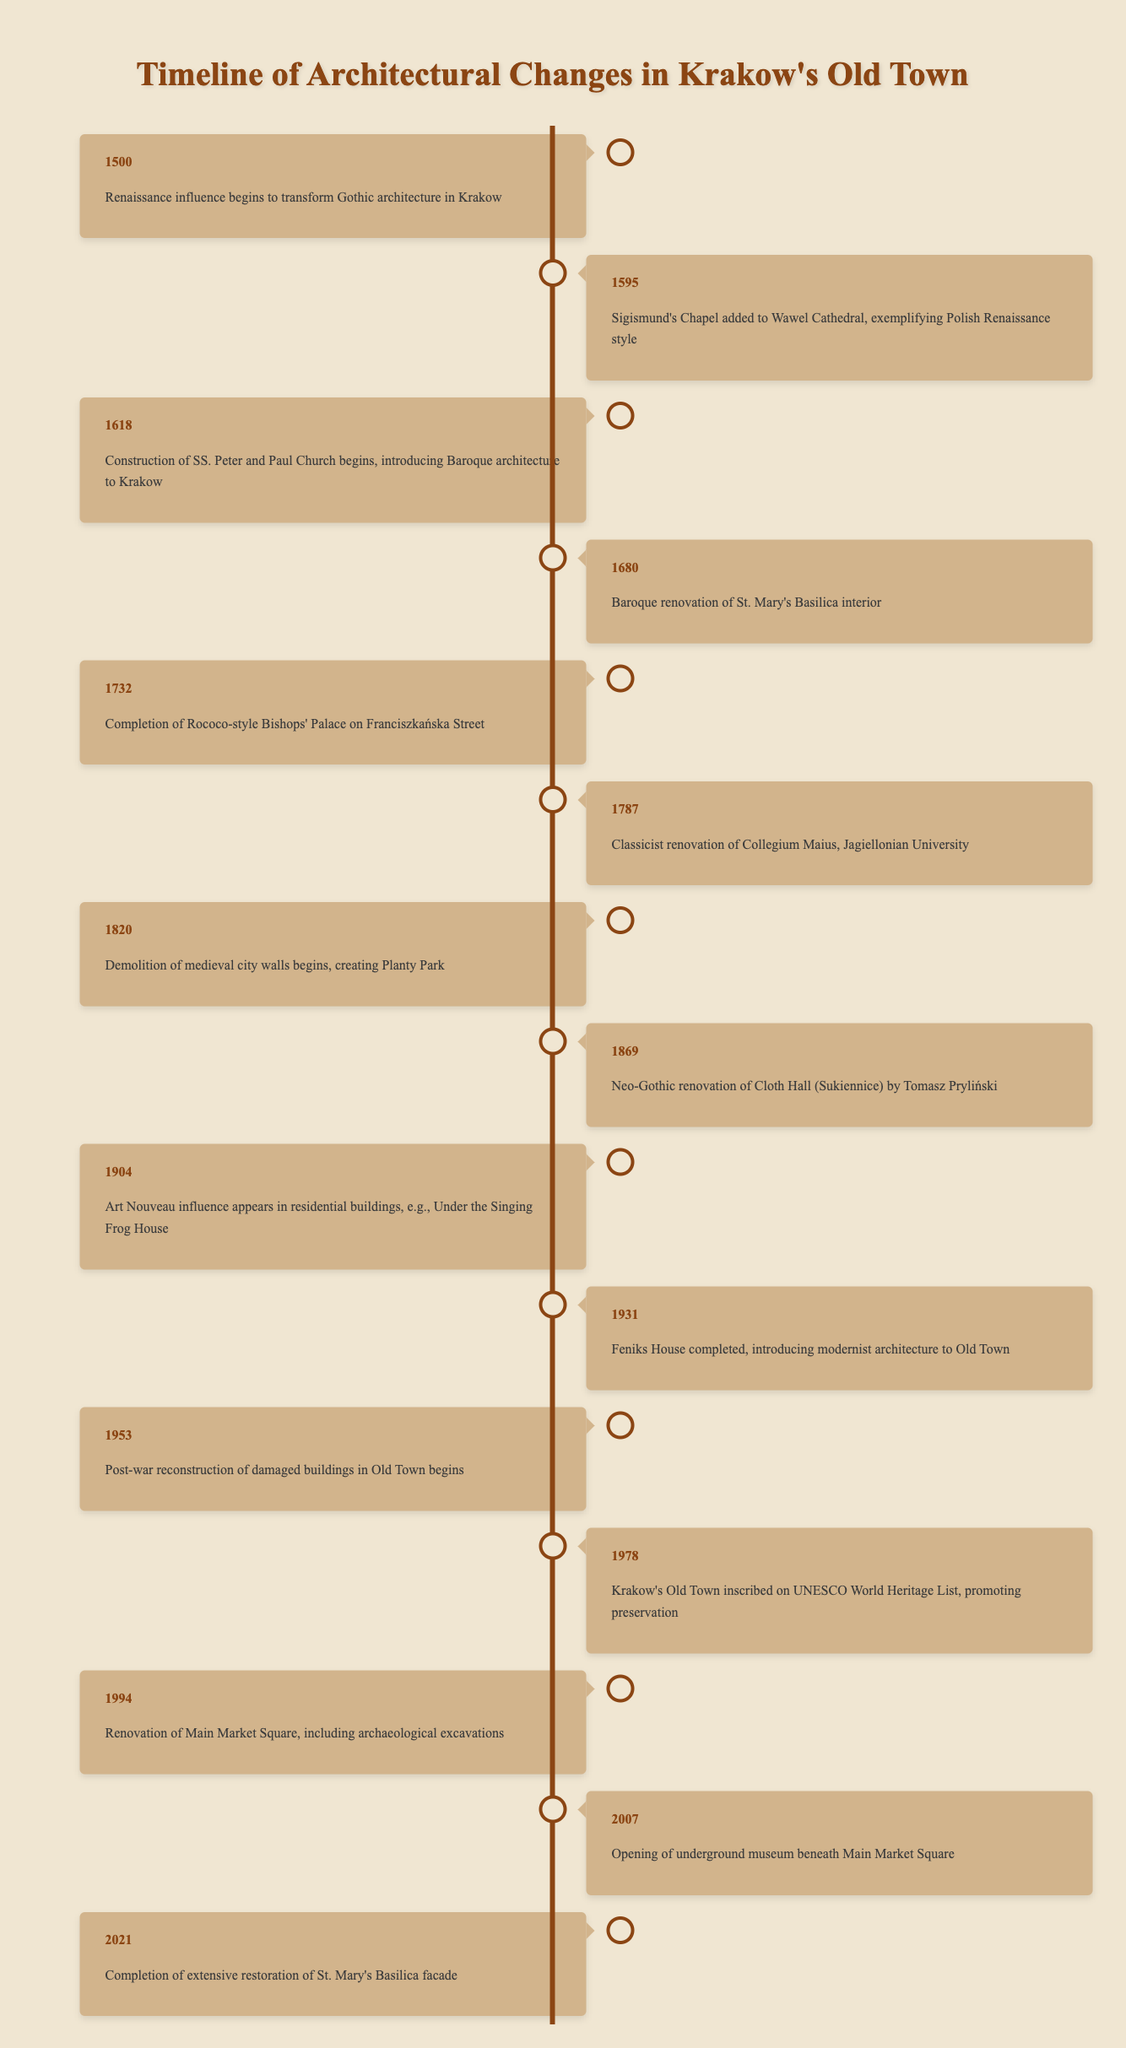What architectural style began to transform Gothic architecture in Krakow around the year 1500? The table indicates that the Renaissance influence began to transform Gothic architecture in Krakow in the year 1500. This can be found in the first event listed.
Answer: Renaissance What year was the renovation of St. Mary's Basilica's interior completed? According to the timeline, the Baroque renovation of St. Mary's Basilica interior took place in 1680. This event is explicitly stated in the timeline.
Answer: 1680 Was Feniks House completed before or after Krakow's Old Town was inscribed on the UNESCO World Heritage List? Feniks House was completed in 1931 and the UNESCO inscription occurred in 1978. Since 1931 is earlier than 1978, we conclude that Feniks House was completed before the inscription.
Answer: Before How many years passed between the completion of the Rococo-style Bishops' Palace and the Classicist renovation of Collegium Maius? The Bishops' Palace was completed in 1732 and the renovation of Collegium Maius took place in 1787. To find the number of years, subtract 1732 from 1787, resulting in 55 years.
Answer: 55 Did the Art Nouveau influence appear in Krakow's Old Town before 1900? The table indicates that the Art Nouveau influence appeared in 1904. Since this year is after 1900, the statement is false.
Answer: No What significant architectural change occurred in Krakow in the year 1820? The timeline states that in 1820, demolition of medieval city walls began, creating Planty Park. This significant event is clearly mentioned in the events of that year.
Answer: Demolition of medieval city walls In which year did the post-war reconstruction of damaged buildings in Old Town begin? The timeline specifically states that the post-war reconstruction began in 1953. This information is directly listed for that year.
Answer: 1953 What event, according to the timeline, represents the introduction of modernist architecture to Old Town? In 1931, the completion of Feniks House is noted as introducing modernist architecture to the Old Town, according to the table. This association is clearly made.
Answer: Completion of Feniks House Which architectural trend is represented by the construction of SS. Peter and Paul Church, and when did it start? The construction of SS. Peter and Paul Church represents the Baroque architectural trend and began in 1618, as detailed in the timeline.
Answer: Baroque; 1618 